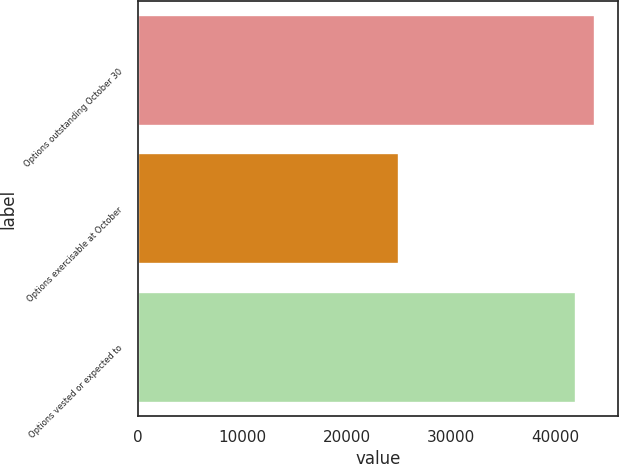Convert chart to OTSL. <chart><loc_0><loc_0><loc_500><loc_500><bar_chart><fcel>Options outstanding October 30<fcel>Options exercisable at October<fcel>Options vested or expected to<nl><fcel>43783.5<fcel>24994<fcel>41975<nl></chart> 